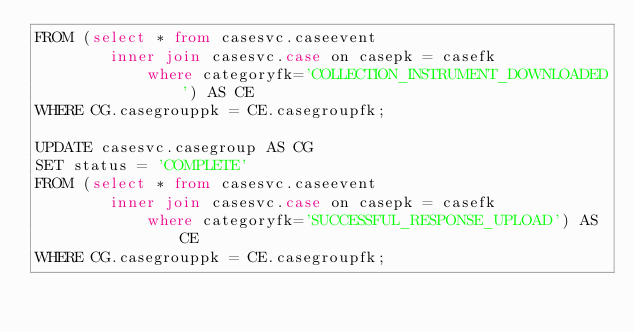Convert code to text. <code><loc_0><loc_0><loc_500><loc_500><_SQL_>FROM (select * from casesvc.caseevent
		inner join casesvc.case on casepk = casefk
     		where categoryfk='COLLECTION_INSTRUMENT_DOWNLOADED') AS CE
WHERE CG.casegrouppk = CE.casegroupfk;

UPDATE casesvc.casegroup AS CG
SET status = 'COMPLETE'
FROM (select * from casesvc.caseevent
		inner join casesvc.case on casepk = casefk
     		where categoryfk='SUCCESSFUL_RESPONSE_UPLOAD') AS CE
WHERE CG.casegrouppk = CE.casegroupfk;</code> 